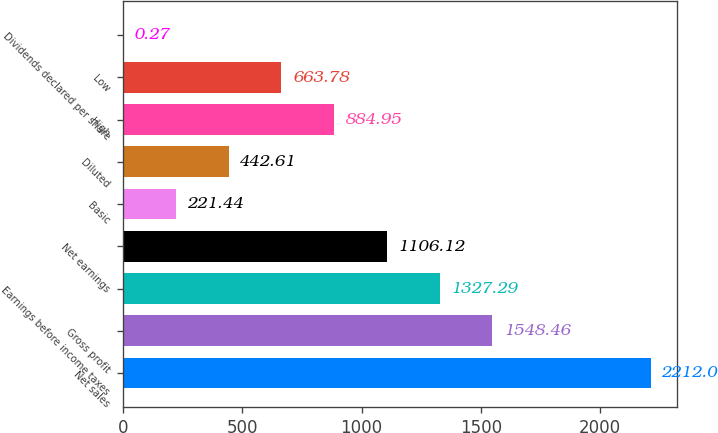Convert chart. <chart><loc_0><loc_0><loc_500><loc_500><bar_chart><fcel>Net sales<fcel>Gross profit<fcel>Earnings before income taxes<fcel>Net earnings<fcel>Basic<fcel>Diluted<fcel>High<fcel>Low<fcel>Dividends declared per share<nl><fcel>2212<fcel>1548.46<fcel>1327.29<fcel>1106.12<fcel>221.44<fcel>442.61<fcel>884.95<fcel>663.78<fcel>0.27<nl></chart> 